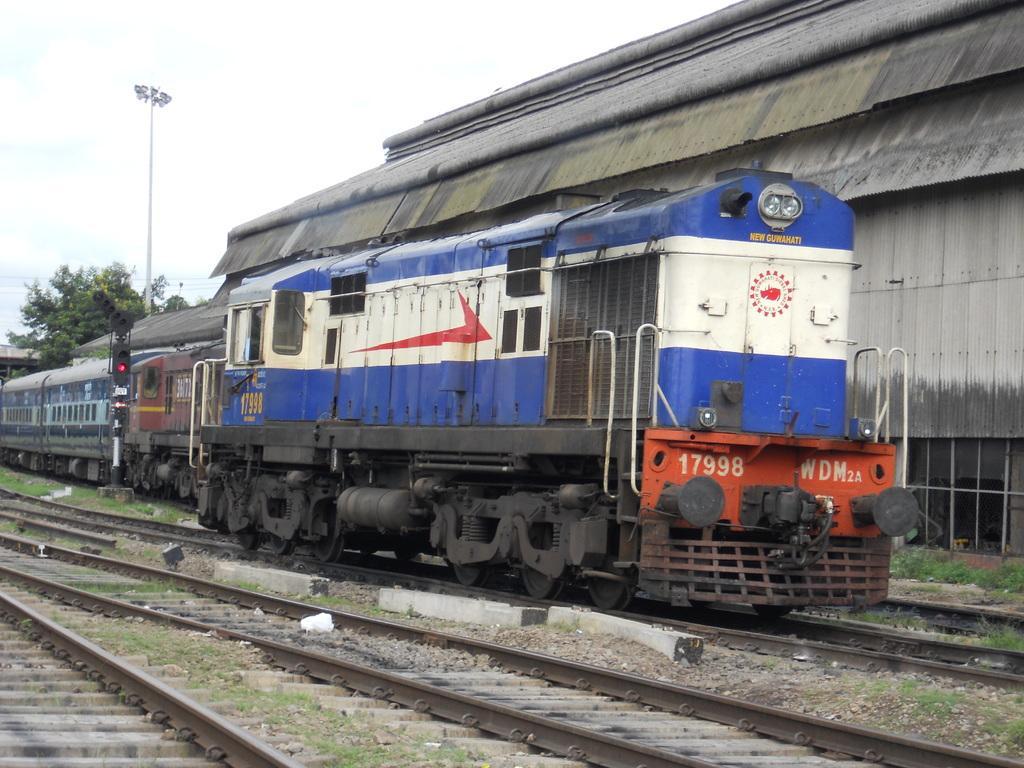In one or two sentences, can you explain what this image depicts? In this image we can see a train and there is some text on it. There are few railway tracks in the image. There is a tree in the image. There are few plants in the image. We can see few plants in the image. There is a shed in the image. 